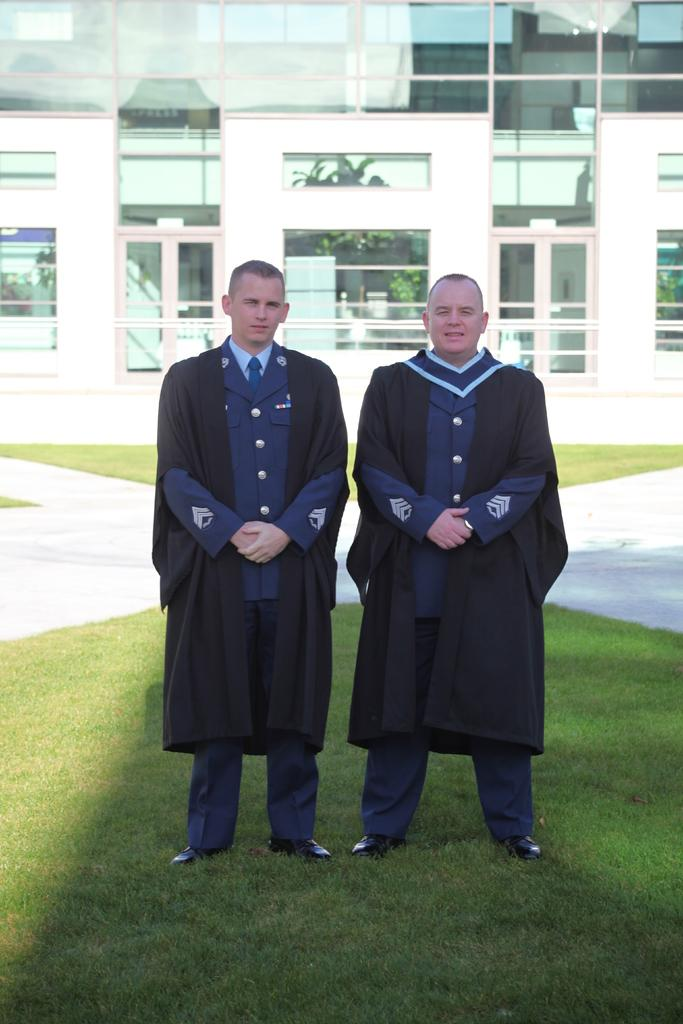How many people are present in the image? There are two people standing in the image. What is located behind the people? There is a building behind the people. What type of grape is being used as a hat by one of the people in the image? There is no grape present in the image, nor is any person wearing a grape as a hat. 